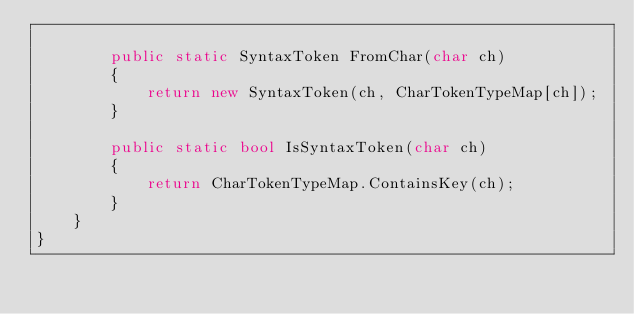<code> <loc_0><loc_0><loc_500><loc_500><_C#_>
		public static SyntaxToken FromChar(char ch)
		{
			return new SyntaxToken(ch, CharTokenTypeMap[ch]);
		}

		public static bool IsSyntaxToken(char ch)
		{
			return CharTokenTypeMap.ContainsKey(ch);
		}
	}
}</code> 